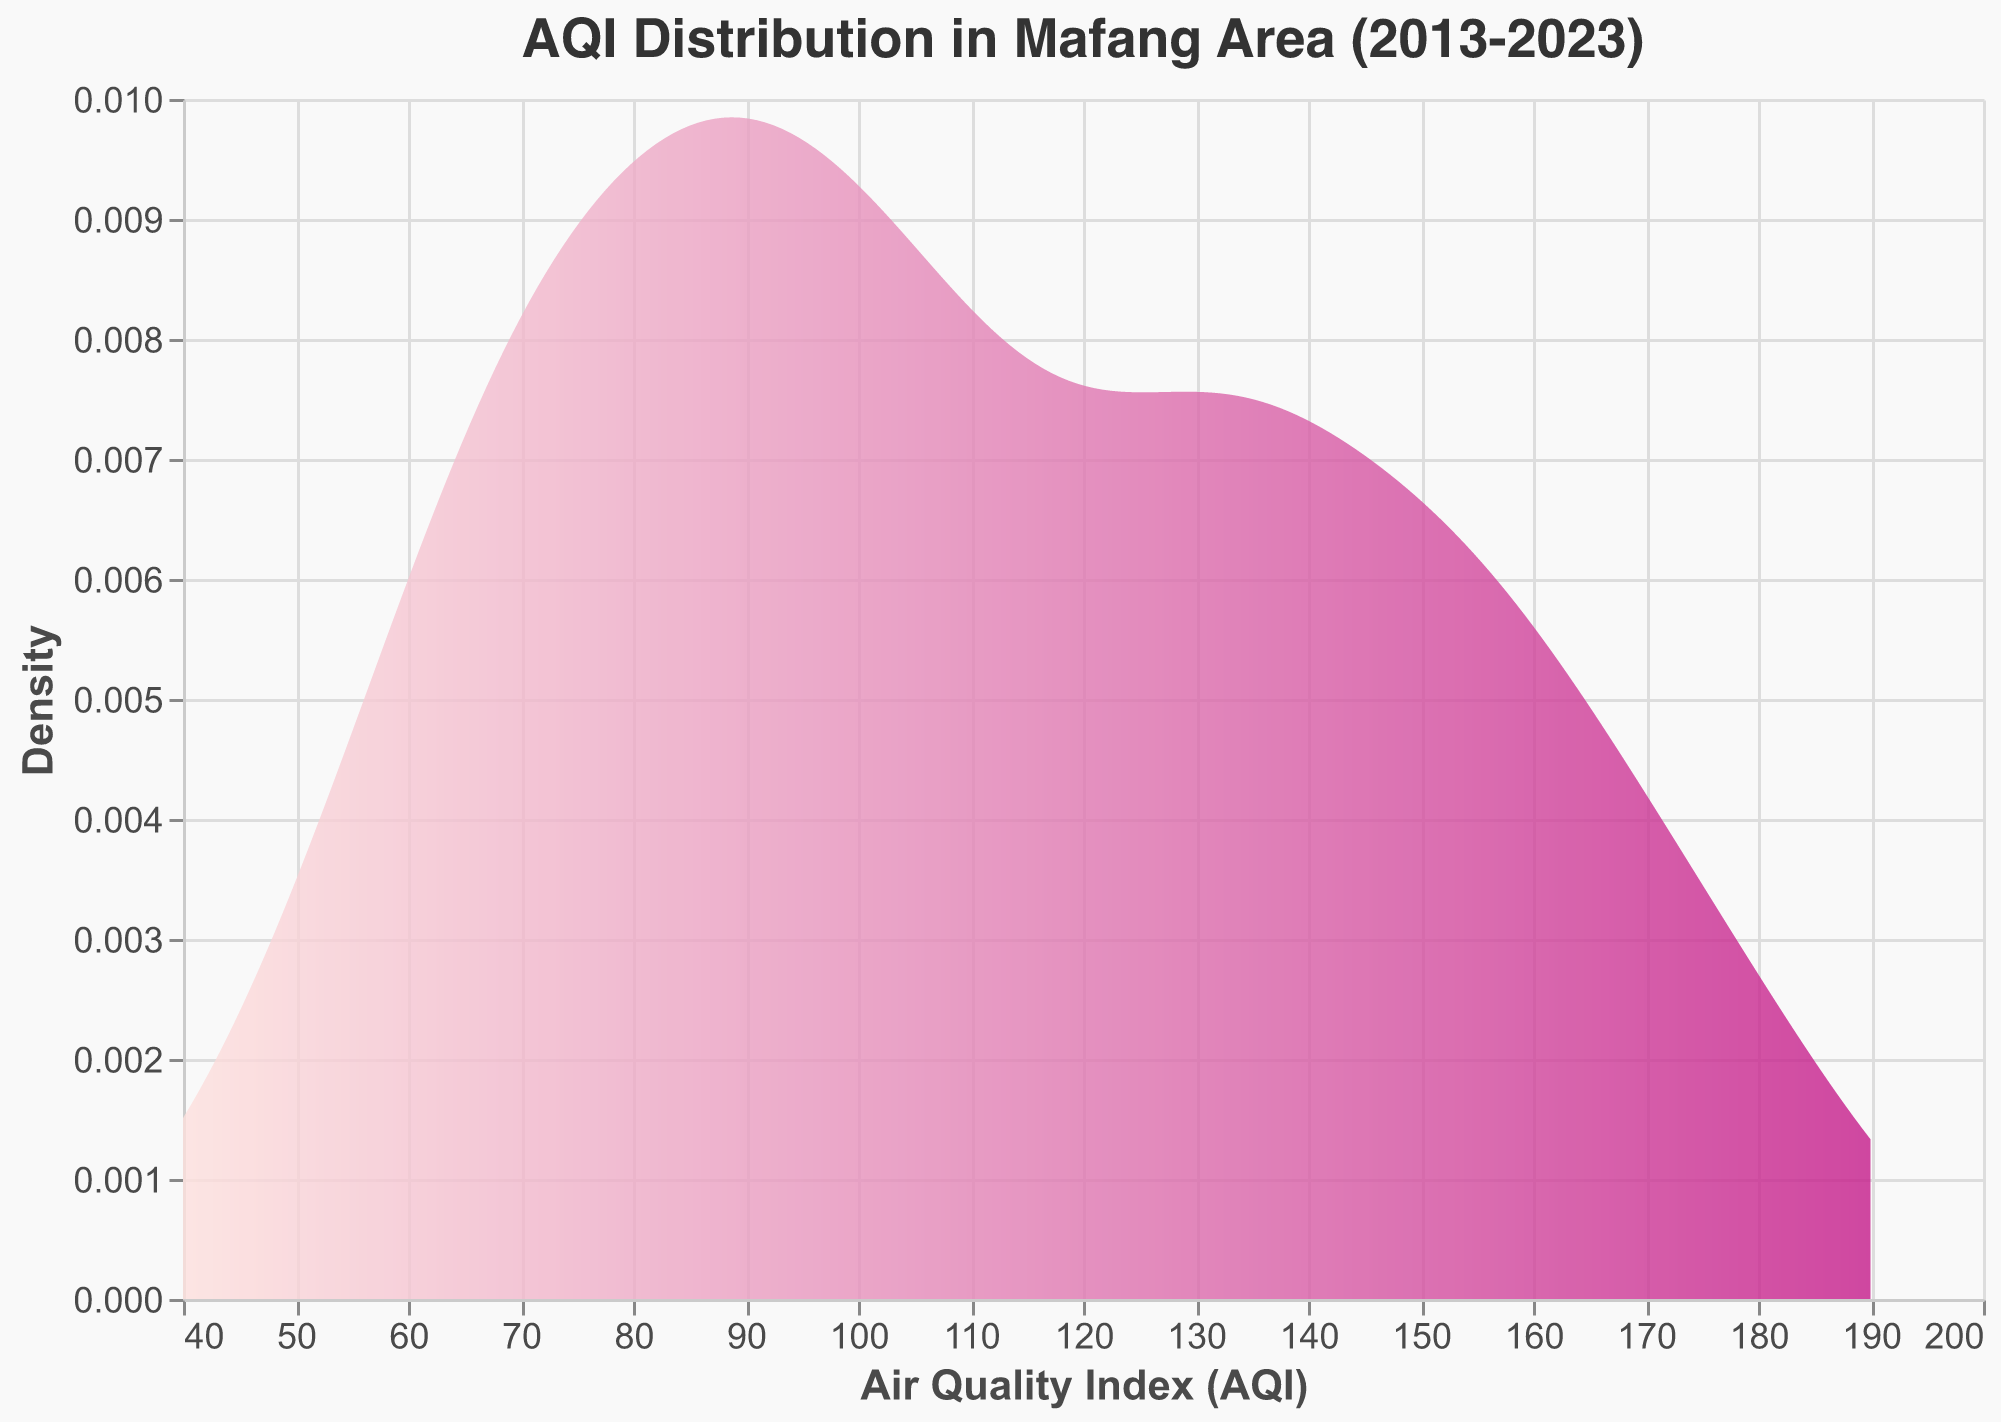What is the title of the figure? The title of the figure is displayed at the top and reads "AQI Distribution in Mafang Area (2013-2023)".
Answer: AQI Distribution in Mafang Area (2013-2023) What does the x-axis represent in the figure? The x-axis of the figure is labeled as "Air Quality Index (AQI)", which indicates the different AQI values that have been recorded.
Answer: Air Quality Index (AQI) What is the shape of the overall AQI distribution? The overall AQI distribution is shown by a smooth, continuous curve that represents the density estimation of AQI values. The curve starts high at lower AQI values, gradually increases to a peak, and then declines, following a symmetric pattern.
Answer: A symmetric bell-shaped curve At approximately which AQI value does the peak density occur? The peak density of the AQI distribution curve appears roughly around the AQI value of 100, as the curve reaches its highest point there.
Answer: Around 100 How has the AQI improved over the past decade in Mafang Area based on the density plot? To determine AQI improvement, look for the shift in the density curve towards lower AQI values over time. The densest regions of the curve have shifted leftwards, signaling decreased AQI values in recent years.
Answer: AQI has improved, shifting towards lower values What is the range of AQI values where the density is highest? The highest density spans an AQI range centered around 90 to 120, indicating that most AQI values fall within this interval.
Answer: 90 to 120 How does the coloring of the curve change along the x-axis? The color gradient of the curve shifts from a light pink at lower AQI values to a dark magenta at higher AQI values, indicating varying AQI densities.
Answer: Light pink to dark magenta Compare the densities of AQI values at 70 and 150. Which is higher? By comparing the density values at AQI 70 and AQI 150 on the y-axis, the density at AQI 70 is higher than at AQI 150, as the curve's height is greater around 70.
Answer: Density at AQI 70 is higher What is the implication of the density curve touching the x-axis at extreme AQI values? When the density curve touches the x-axis at extreme AQI values, it indicates that those AQI values are rare or have extremely low density in the observed data.
Answer: Rare AQI values Estimate the average AQI value distribution in Mafang Area over the decade. By looking at the distribution, the average AQI value can be estimated to be around the peak of the density curve, which is approximately 100. This value reflects where most AQI values are concentrated.
Answer: Around 100 